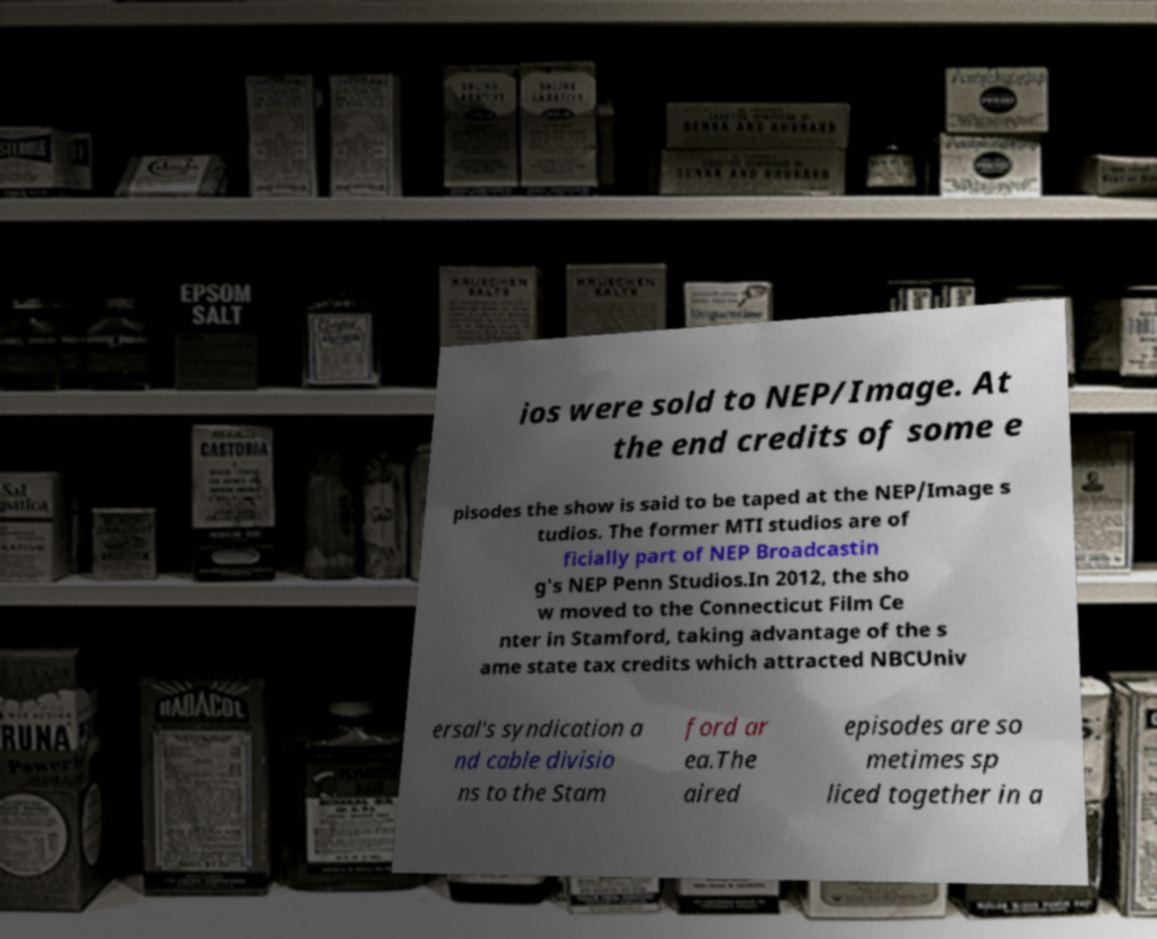Can you accurately transcribe the text from the provided image for me? ios were sold to NEP/Image. At the end credits of some e pisodes the show is said to be taped at the NEP/Image s tudios. The former MTI studios are of ficially part of NEP Broadcastin g's NEP Penn Studios.In 2012, the sho w moved to the Connecticut Film Ce nter in Stamford, taking advantage of the s ame state tax credits which attracted NBCUniv ersal's syndication a nd cable divisio ns to the Stam ford ar ea.The aired episodes are so metimes sp liced together in a 